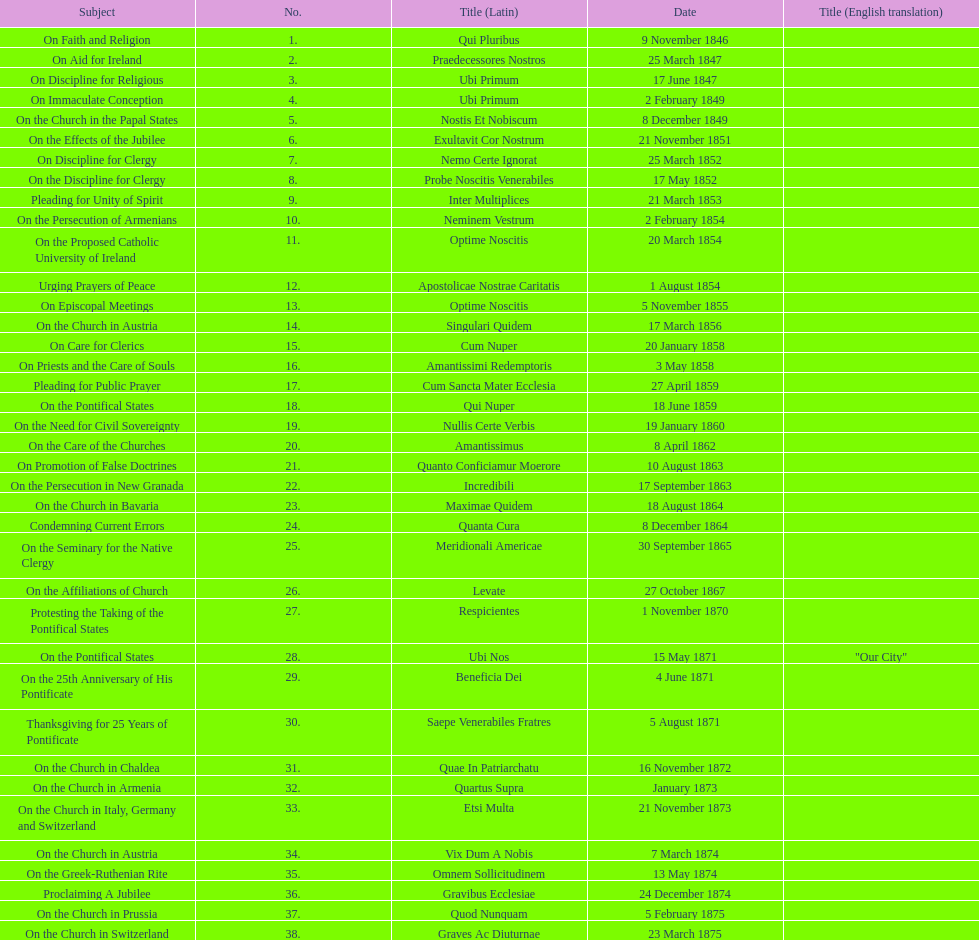Latin title of the encyclical before the encyclical with the subject "on the church in bavaria" Incredibili. 